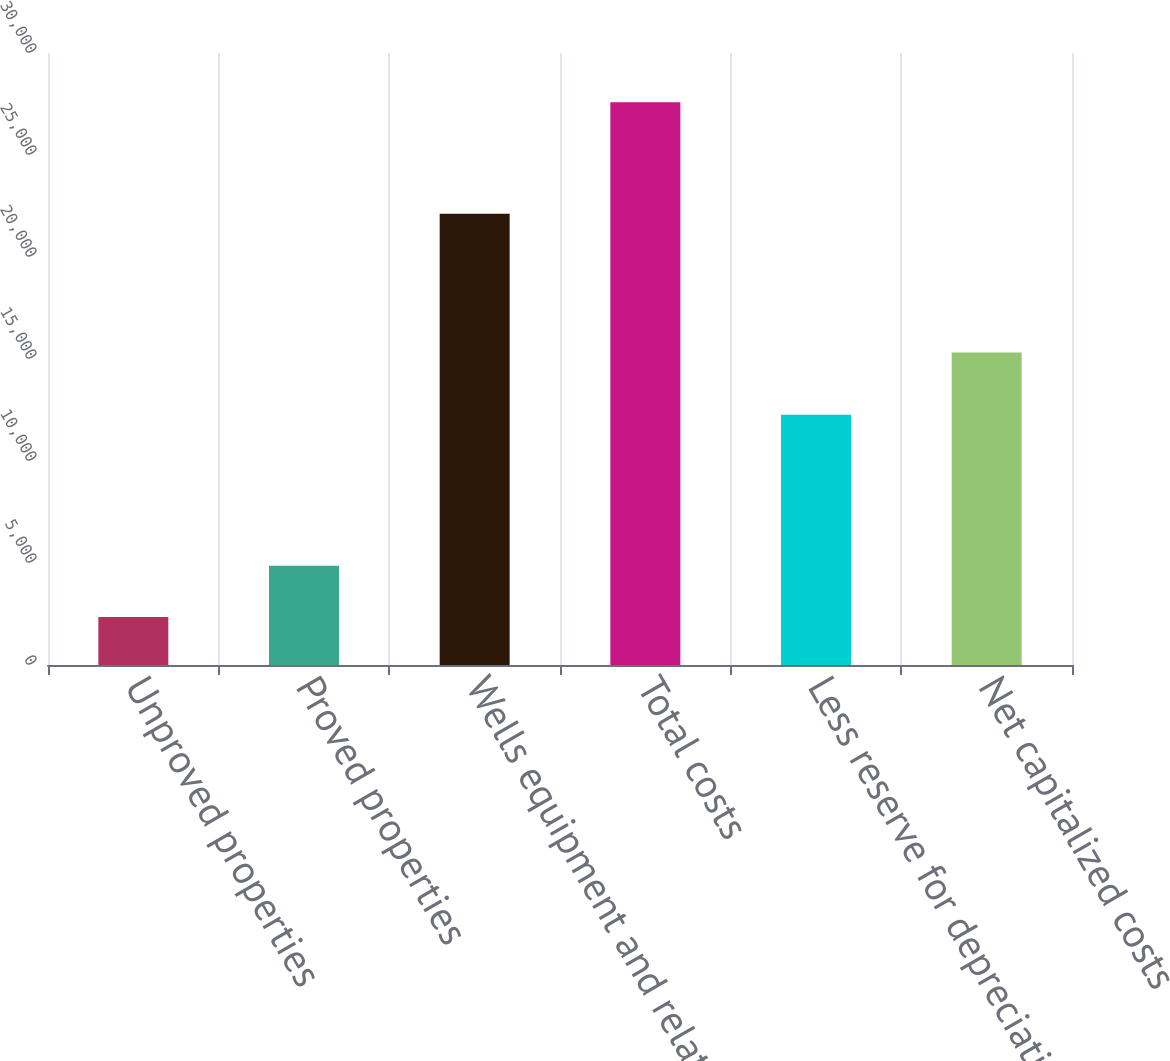Convert chart to OTSL. <chart><loc_0><loc_0><loc_500><loc_500><bar_chart><fcel>Unproved properties<fcel>Proved properties<fcel>Wells equipment and related<fcel>Total costs<fcel>Less reserve for depreciation<fcel>Net capitalized costs<nl><fcel>2347<fcel>4870.9<fcel>22118<fcel>27586<fcel>12273<fcel>15313<nl></chart> 